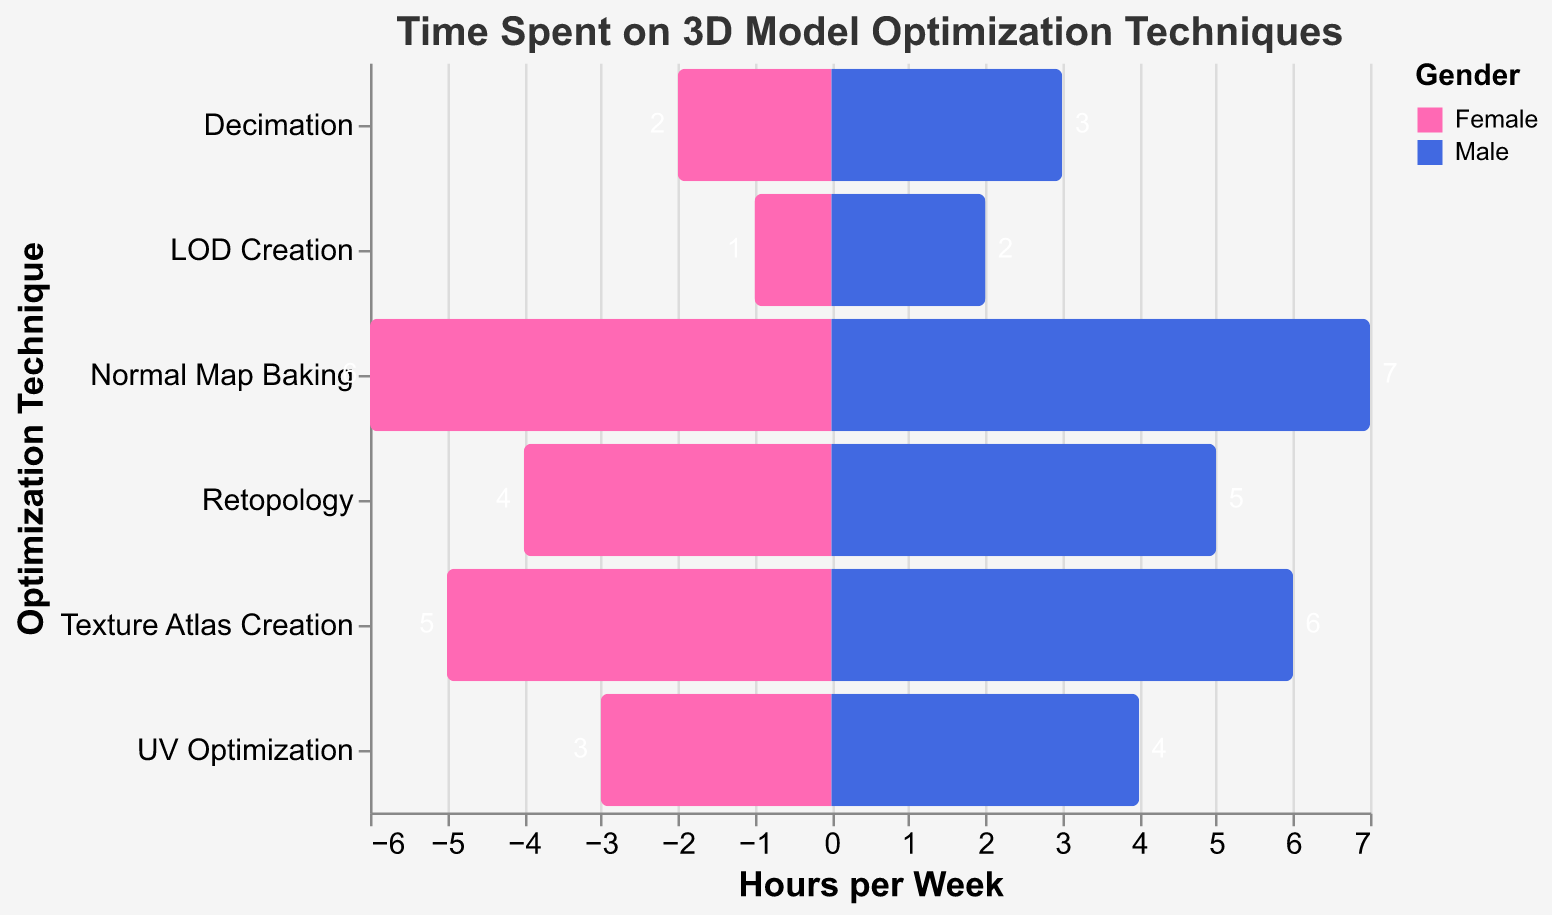What is the title of the chart? The title of the chart is located at the top and describes the main subject of the visualization. In this case, the title specifies the topic as "Time Spent on 3D Model Optimization Techniques".
Answer: Time Spent on 3D Model Optimization Techniques Which technique do beginners spend the most hours on? For beginners, the bars associated with "Decimation" have higher values compared to the "LOD Creation" bars, indicating that they spend more hours on "Decimation".
Answer: Decimation How many hours per week do female experts spend on Normal Map Baking? Looking at the bar for female experts under the "Normal Map Baking" technique, the value represented is shown as 6 hours per week.
Answer: 6 Are there any techniques where male and female hours spent are equal? By examining each technique's bars, all show different values between genders for hours spent, so none of the techniques have equal hours for males and females.
Answer: No Which gender spends more hours on UV Optimization at the intermediate level? For intermediate level on "UV Optimization", the bar representing males is higher than the bar representing females, meaning males spend more hours.
Answer: Male What is the difference in hours spent on Texture Atlas Creation between male and female experts? For "Texture Atlas Creation" among experts, males spend 6 hours per week while females spend 5 hours. The difference between these values is 1 hour (6 - 5 = 1).
Answer: 1 Which experience level spends the least hours on any technique? Beginners spend the least hours on "LOD Creation" as their bars show the lowest values, specifically 1 hour for females and 2 hours for males.
Answer: Beginner How many total hours do beginner females spend on optimization techniques per week? For beginner females, the total hours are the sum of hours spent on "Decimation" (2) and "LOD Creation" (1). So, 2 + 1 = 3 hours.
Answer: 3 Which optimization technique has the highest average hours per week across all experience levels and genders? Calculating the average for each technique: 
- Decimation: (2 + 3)/2 = 2.5 hours,
- LOD Creation: (1 + 2)/2 = 1.5 hours,
- Retopology: (4 + 5)/2 = 4.5 hours,
- UV Optimization: (3 + 4)/2 = 3.5 hours,
- Normal Map Baking: (6 + 7)/2 = 6.5 hours,
- Texture Atlas Creation: (5 + 6)/2 = 5.5 hours.
The highest average is for "Normal Map Baking" with 6.5 hours.
Answer: Normal Map Baking How does the time spent on optimization techniques vary between males and females across all experience levels? Summing the hours for males and females respectively:
- Males: 3 + 2 + 5 + 4 + 7 + 6 = 27 hours.
- Females: 2 + 1 + 4 + 3 + 6 + 5 = 21 hours.
Males spend more hours in total compared to females across all levels and techniques (27 > 21).
Answer: Males spend more hours 